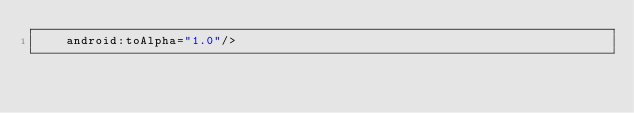<code> <loc_0><loc_0><loc_500><loc_500><_XML_>    android:toAlpha="1.0"/>
</code> 